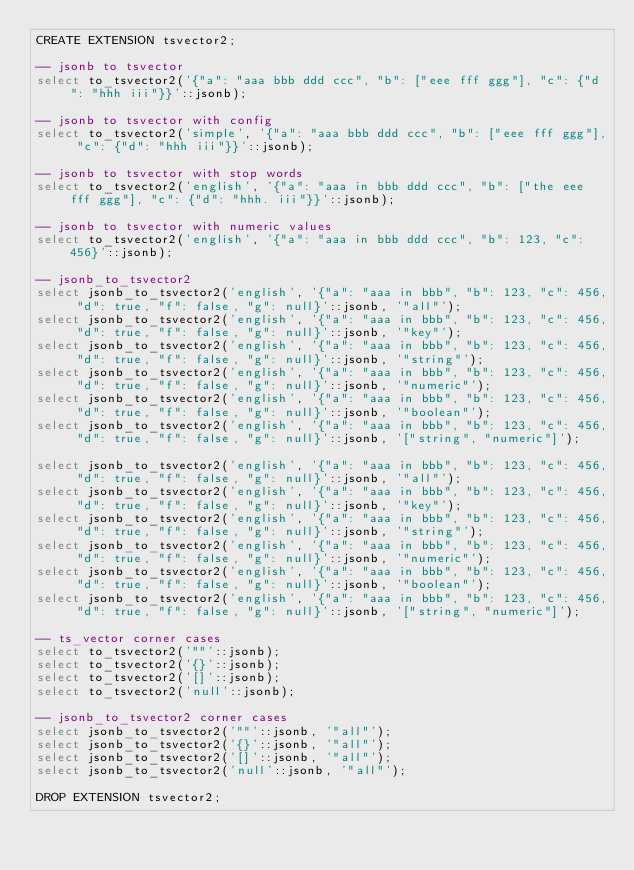<code> <loc_0><loc_0><loc_500><loc_500><_SQL_>CREATE EXTENSION tsvector2;

-- jsonb to tsvector
select to_tsvector2('{"a": "aaa bbb ddd ccc", "b": ["eee fff ggg"], "c": {"d": "hhh iii"}}'::jsonb);

-- jsonb to tsvector with config
select to_tsvector2('simple', '{"a": "aaa bbb ddd ccc", "b": ["eee fff ggg"], "c": {"d": "hhh iii"}}'::jsonb);

-- jsonb to tsvector with stop words
select to_tsvector2('english', '{"a": "aaa in bbb ddd ccc", "b": ["the eee fff ggg"], "c": {"d": "hhh. iii"}}'::jsonb);

-- jsonb to tsvector with numeric values
select to_tsvector2('english', '{"a": "aaa in bbb ddd ccc", "b": 123, "c": 456}'::jsonb);

-- jsonb_to_tsvector2
select jsonb_to_tsvector2('english', '{"a": "aaa in bbb", "b": 123, "c": 456, "d": true, "f": false, "g": null}'::jsonb, '"all"');
select jsonb_to_tsvector2('english', '{"a": "aaa in bbb", "b": 123, "c": 456, "d": true, "f": false, "g": null}'::jsonb, '"key"');
select jsonb_to_tsvector2('english', '{"a": "aaa in bbb", "b": 123, "c": 456, "d": true, "f": false, "g": null}'::jsonb, '"string"');
select jsonb_to_tsvector2('english', '{"a": "aaa in bbb", "b": 123, "c": 456, "d": true, "f": false, "g": null}'::jsonb, '"numeric"');
select jsonb_to_tsvector2('english', '{"a": "aaa in bbb", "b": 123, "c": 456, "d": true, "f": false, "g": null}'::jsonb, '"boolean"');
select jsonb_to_tsvector2('english', '{"a": "aaa in bbb", "b": 123, "c": 456, "d": true, "f": false, "g": null}'::jsonb, '["string", "numeric"]');

select jsonb_to_tsvector2('english', '{"a": "aaa in bbb", "b": 123, "c": 456, "d": true, "f": false, "g": null}'::jsonb, '"all"');
select jsonb_to_tsvector2('english', '{"a": "aaa in bbb", "b": 123, "c": 456, "d": true, "f": false, "g": null}'::jsonb, '"key"');
select jsonb_to_tsvector2('english', '{"a": "aaa in bbb", "b": 123, "c": 456, "d": true, "f": false, "g": null}'::jsonb, '"string"');
select jsonb_to_tsvector2('english', '{"a": "aaa in bbb", "b": 123, "c": 456, "d": true, "f": false, "g": null}'::jsonb, '"numeric"');
select jsonb_to_tsvector2('english', '{"a": "aaa in bbb", "b": 123, "c": 456, "d": true, "f": false, "g": null}'::jsonb, '"boolean"');
select jsonb_to_tsvector2('english', '{"a": "aaa in bbb", "b": 123, "c": 456, "d": true, "f": false, "g": null}'::jsonb, '["string", "numeric"]');

-- ts_vector corner cases
select to_tsvector2('""'::jsonb);
select to_tsvector2('{}'::jsonb);
select to_tsvector2('[]'::jsonb);
select to_tsvector2('null'::jsonb);

-- jsonb_to_tsvector2 corner cases
select jsonb_to_tsvector2('""'::jsonb, '"all"');
select jsonb_to_tsvector2('{}'::jsonb, '"all"');
select jsonb_to_tsvector2('[]'::jsonb, '"all"');
select jsonb_to_tsvector2('null'::jsonb, '"all"');

DROP EXTENSION tsvector2;
</code> 